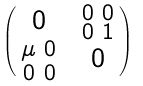Convert formula to latex. <formula><loc_0><loc_0><loc_500><loc_500>\begin{pmatrix} 0 & \begin{smallmatrix} 0 & 0 \\ 0 & 1 \end{smallmatrix} \\ \begin{smallmatrix} \mu & 0 \\ 0 & 0 \end{smallmatrix} & 0 \\ \end{pmatrix}</formula> 